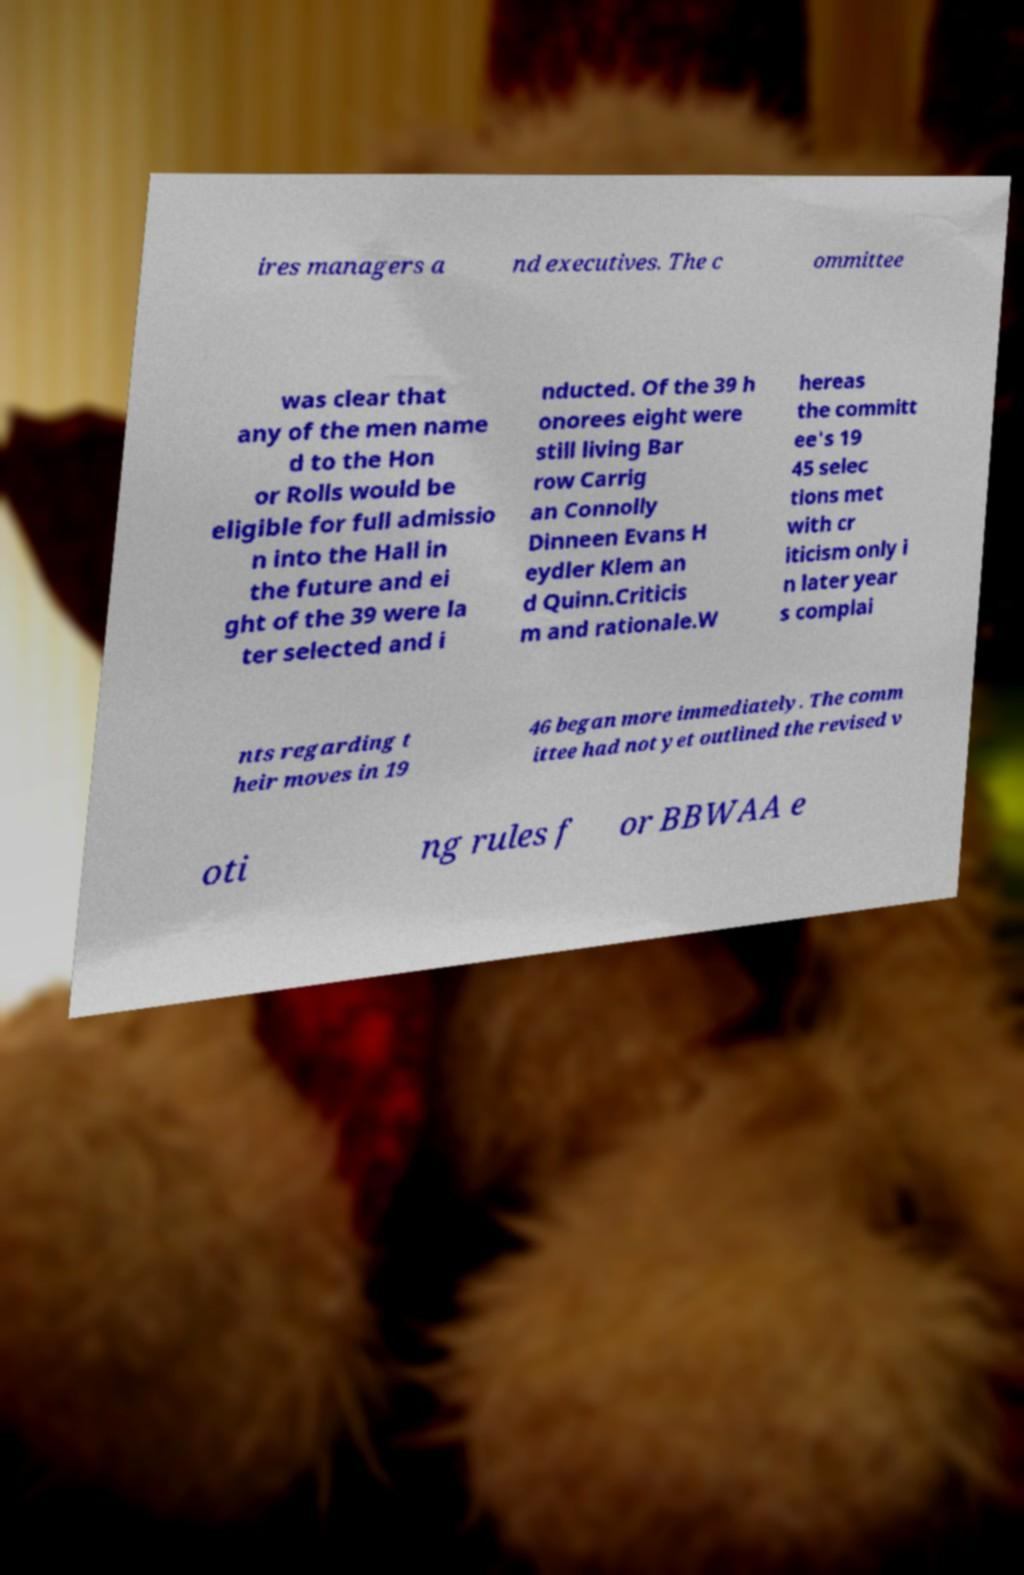Can you read and provide the text displayed in the image?This photo seems to have some interesting text. Can you extract and type it out for me? ires managers a nd executives. The c ommittee was clear that any of the men name d to the Hon or Rolls would be eligible for full admissio n into the Hall in the future and ei ght of the 39 were la ter selected and i nducted. Of the 39 h onorees eight were still living Bar row Carrig an Connolly Dinneen Evans H eydler Klem an d Quinn.Criticis m and rationale.W hereas the committ ee's 19 45 selec tions met with cr iticism only i n later year s complai nts regarding t heir moves in 19 46 began more immediately. The comm ittee had not yet outlined the revised v oti ng rules f or BBWAA e 